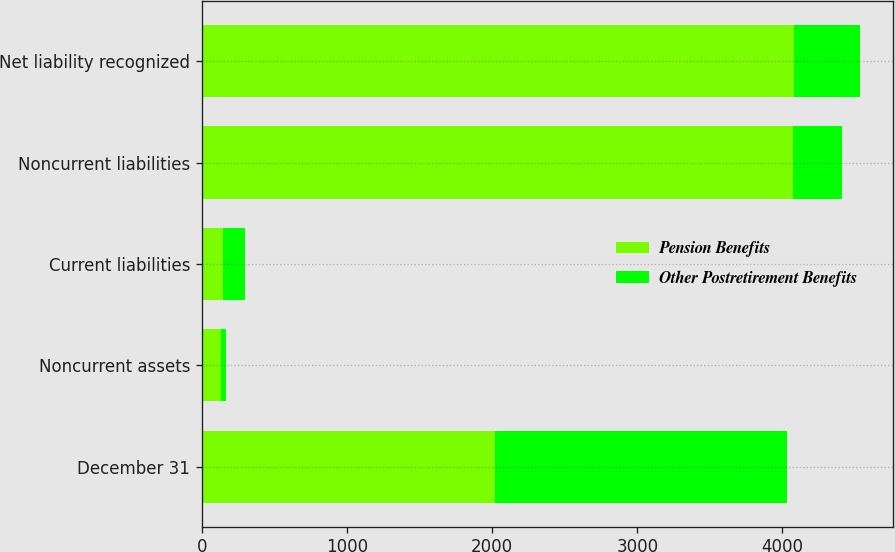<chart> <loc_0><loc_0><loc_500><loc_500><stacked_bar_chart><ecel><fcel>December 31<fcel>Noncurrent assets<fcel>Current liabilities<fcel>Noncurrent liabilities<fcel>Net liability recognized<nl><fcel>Pension Benefits<fcel>2017<fcel>133<fcel>145<fcel>4070<fcel>4082<nl><fcel>Other Postretirement Benefits<fcel>2017<fcel>33<fcel>150<fcel>338<fcel>455<nl></chart> 